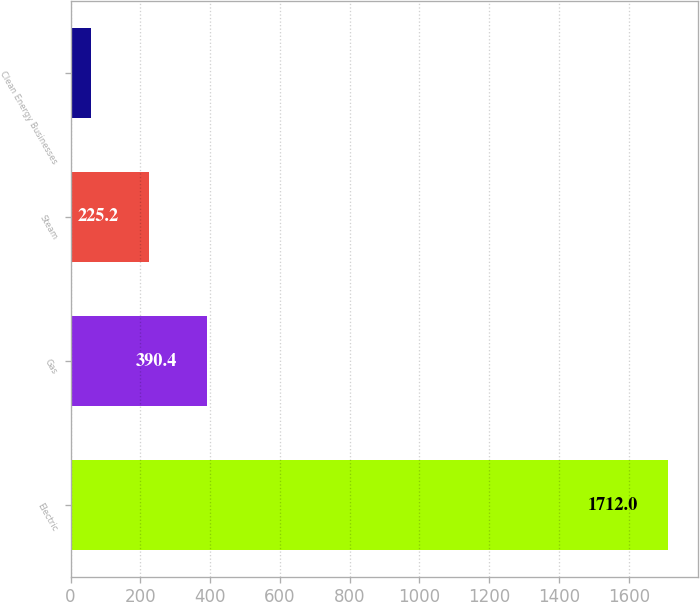<chart> <loc_0><loc_0><loc_500><loc_500><bar_chart><fcel>Electric<fcel>Gas<fcel>Steam<fcel>Clean Energy Businesses<nl><fcel>1712<fcel>390.4<fcel>225.2<fcel>60<nl></chart> 